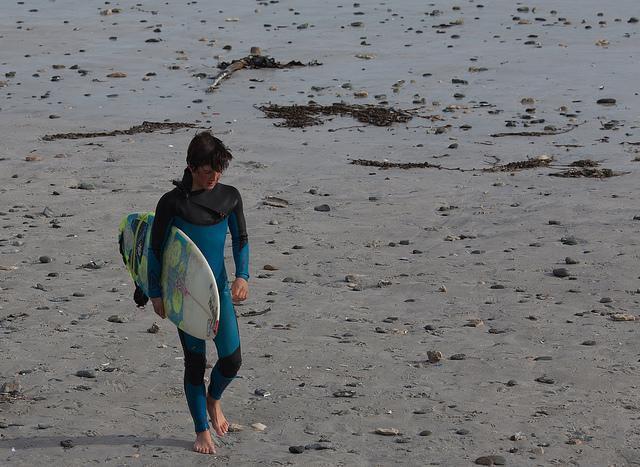How many people in the photo?
Give a very brief answer. 1. How many toes on each foot?
Give a very brief answer. 5. How many people are holding surfboards?
Give a very brief answer. 1. How many surfboards are there?
Give a very brief answer. 1. 